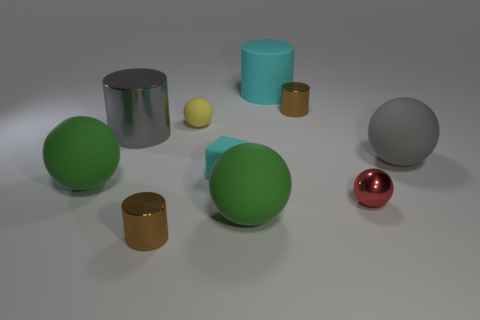Subtract 1 balls. How many balls are left? 4 Subtract all purple balls. Subtract all blue cubes. How many balls are left? 5 Subtract all cylinders. How many objects are left? 6 Subtract all large cylinders. Subtract all tiny spheres. How many objects are left? 6 Add 1 tiny cyan objects. How many tiny cyan objects are left? 2 Add 7 large gray cylinders. How many large gray cylinders exist? 8 Subtract 0 red cubes. How many objects are left? 10 